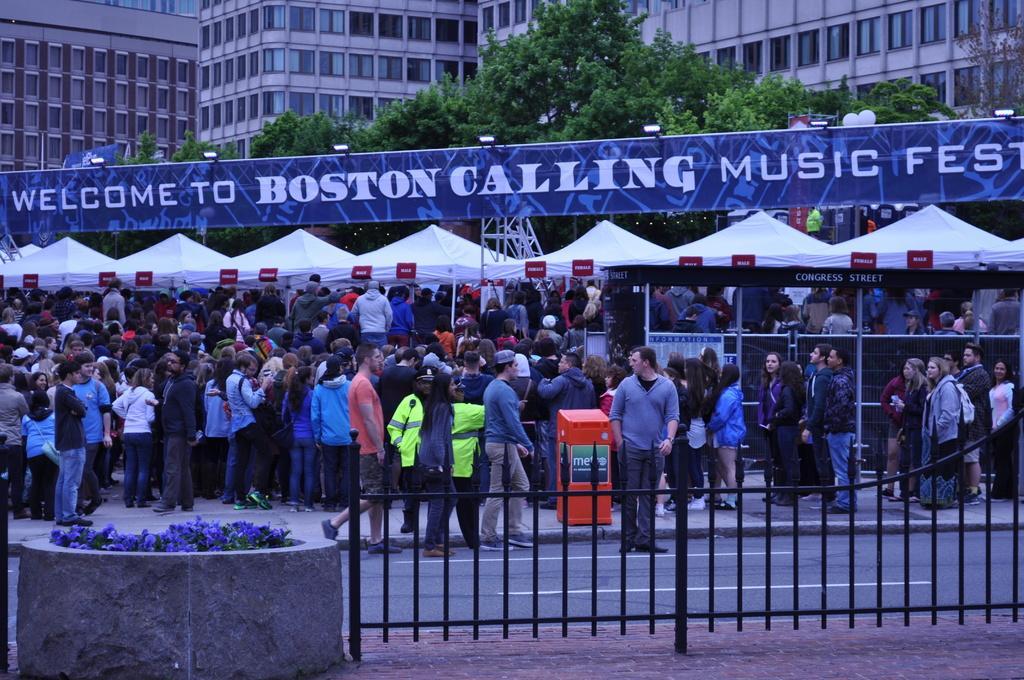Describe this image in one or two sentences. In this image there are people standing on the pavement. Middle of the image there are tents. There is a board attached to the metal rods. On the board there is some text. Few lights are attached to the board. There is an object on the pavement. Few people are on the road. Bottom of the image there is a fence on the pavement. Left bottom there are plants surrounded by a wall. Background there are buildings and trees. 